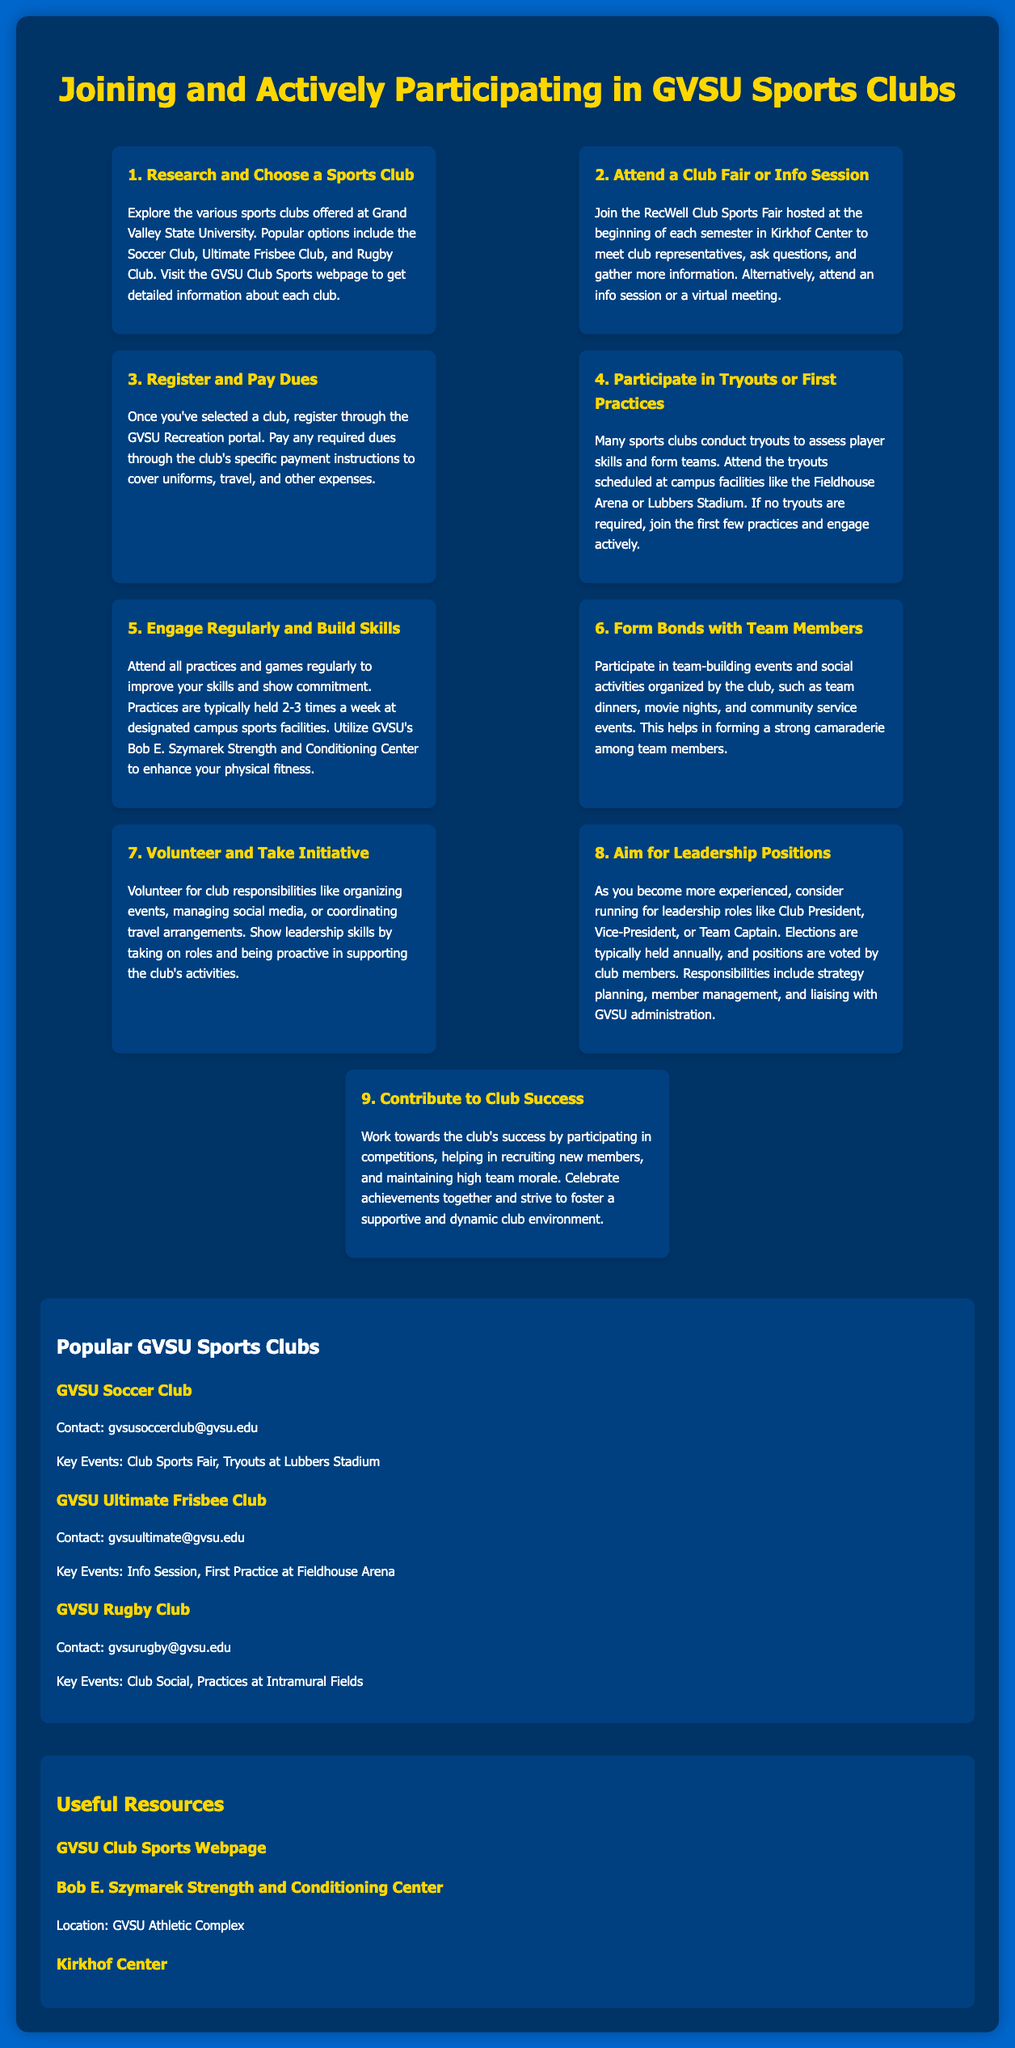What is the first step to join a sports club? The first step is to research and choose a sports club available at Grand Valley State University.
Answer: Research and Choose a Sports Club Where is the Club Sports Fair held? The Club Sports Fair is hosted at the Kirkhof Center at the beginning of each semester.
Answer: Kirkhof Center What must you do after selecting a club? After selecting a club, you must register through the GVSU Recreation portal and pay any required dues.
Answer: Register and Pay Dues How often are practices typically held? Practices are typically held 2-3 times a week.
Answer: 2-3 times a week What is an event that helps form bonds among team members? Team-building events such as team dinners help in forming bonds among team members.
Answer: Team dinners What leadership role can you aim for after gaining experience? You can aim for roles like Club President, Vice-President, or Team Captain.
Answer: Club President What is a key focus for contributing to the club's success? Participating in competitions is a key focus for contributing to the club's success.
Answer: Participating in competitions What is the contact email for the GVSU Soccer Club? The contact email for the GVSU Soccer Club is gvsusoccerclub@gvsu.edu.
Answer: gvsusoccerclub@gvsu.edu What facility is mentioned for enhancing physical fitness? The Bob E. Szymarek Strength and Conditioning Center is mentioned for enhancing physical fitness.
Answer: Bob E. Szymarek Strength and Conditioning Center 